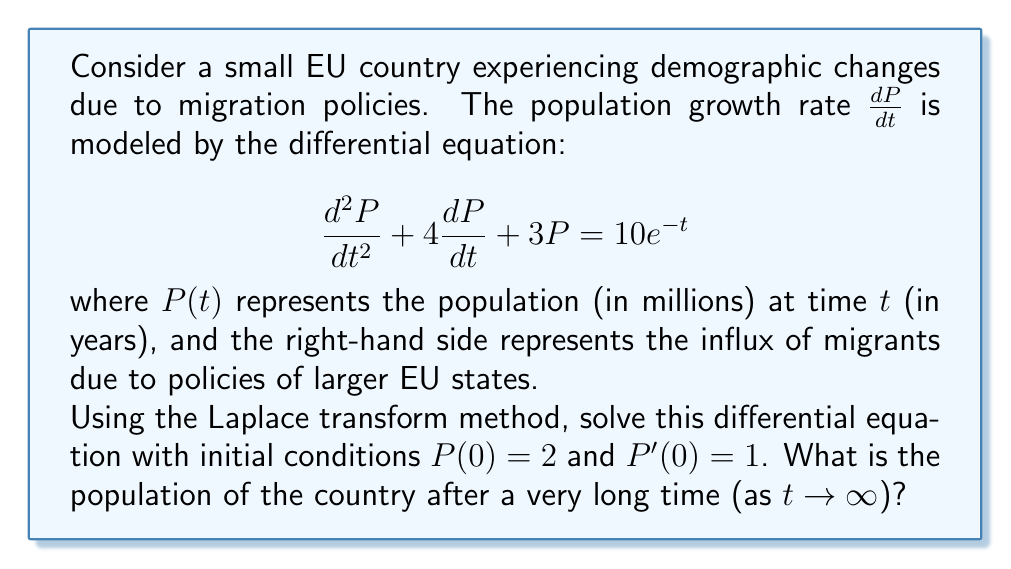Show me your answer to this math problem. Let's solve this step-by-step using the Laplace transform method:

1) Take the Laplace transform of both sides of the equation:
   $$\mathcal{L}\left\{\frac{d^2P}{dt^2} + 4\frac{dP}{dt} + 3P\right\} = \mathcal{L}\{10e^{-t}\}$$

2) Using Laplace transform properties:
   $$s^2P(s) - sP(0) - P'(0) + 4[sP(s) - P(0)] + 3P(s) = \frac{10}{s+1}$$

3) Substitute the initial conditions $P(0) = 2$ and $P'(0) = 1$:
   $$s^2P(s) - 2s - 1 + 4sP(s) - 8 + 3P(s) = \frac{10}{s+1}$$

4) Collect terms with $P(s)$:
   $$(s^2 + 4s + 3)P(s) = \frac{10}{s+1} + 2s + 9$$

5) Solve for $P(s)$:
   $$P(s) = \frac{10}{(s+1)(s^2 + 4s + 3)} + \frac{2s + 9}{s^2 + 4s + 3}$$

6) Decompose into partial fractions:
   $$P(s) = \frac{A}{s+1} + \frac{B}{s+1} + \frac{C}{s+3} + \frac{2s + 9}{s^2 + 4s + 3}$$

7) Solve for $A$, $B$, and $C$:
   $$A = \frac{5}{2}, B = -\frac{5}{2}, C = \frac{5}{2}$$

8) Take the inverse Laplace transform:
   $$P(t) = \frac{5}{2}e^{-t} - \frac{5}{2}e^{-t} + \frac{5}{2}e^{-3t} + 2e^{-t} - e^{-3t}$$

9) Simplify:
   $$P(t) = 2e^{-t} + \frac{3}{2}e^{-3t}$$

10) To find the population after a very long time, take the limit as $t \to \infty$:
    $$\lim_{t \to \infty} P(t) = \lim_{t \to \infty} (2e^{-t} + \frac{3}{2}e^{-3t}) = 0$$
Answer: $0$ million 